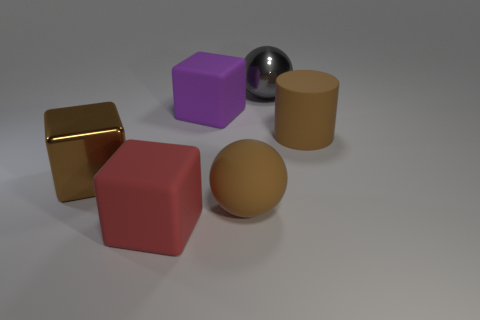Subtract all rubber cubes. How many cubes are left? 1 Subtract all gray balls. How many balls are left? 1 Subtract 1 spheres. How many spheres are left? 1 Add 2 large brown matte cylinders. How many objects exist? 8 Subtract all spheres. How many objects are left? 4 Subtract all green cubes. How many red balls are left? 0 Subtract all small brown blocks. Subtract all cylinders. How many objects are left? 5 Add 5 brown cylinders. How many brown cylinders are left? 6 Add 5 large red blocks. How many large red blocks exist? 6 Subtract 1 brown spheres. How many objects are left? 5 